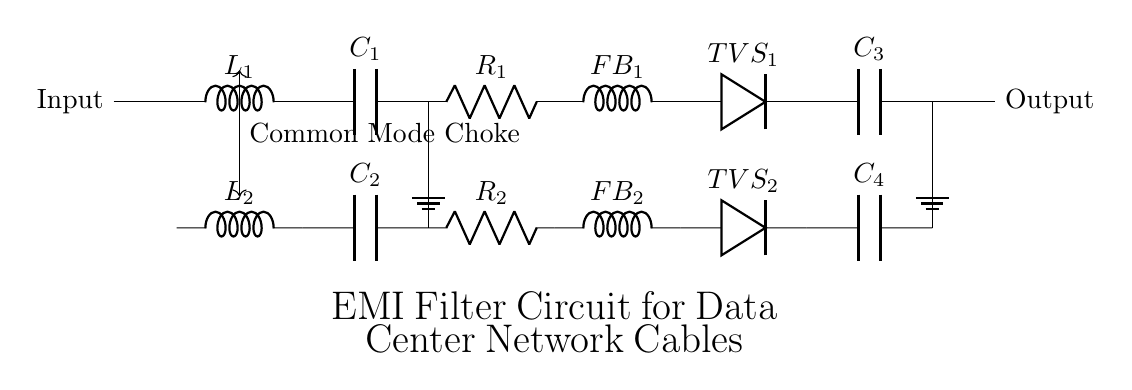What type of filter does this circuit implement? This circuit implements an electromagnetic interference filter, as indicated by the title and the presence of common mode chokes, capacitors, and resistors designed to reduce EMI effects on network cables.
Answer: electromagnetic interference filter How many inductors are present in the circuit? There are four inductors present in the circuit: two common mode chokes and two ferrite beads, which are integral components for filtering EMI.
Answer: four inductors What is connected to ground in this circuit? The circuit shows ground connections for multiple components; specifically, the resistors and output capacitors are connected to the ground to provide a reference point for voltages in the circuit.
Answer: resistors and output capacitors Why are TVS diodes included in this circuit? TVS diodes, or transient voltage suppressors, are included to protect the circuit from voltage spikes or transients, which can occur from EMI or lightning strikes, ensuring the integrity of the data transmission.
Answer: to protect from voltage spikes What is the purpose of the common mode choke in this circuit? The common mode choke is utilized to block high-frequency noise while allowing the desired data signals to pass, thereby helping to maintain signal integrity in the presence of electromagnetic interference.
Answer: to block high-frequency noise What types of components are used in the filtering section of the circuit? The filtering section employs inductors (common mode chokes and ferrite beads), capacitors, and resistors that work together to attenuate unwanted signals and provide a smooth output signal.
Answer: inductors, capacitors, resistors How many capacitors are in the circuit? The circuit contains four capacitors, which play a crucial role in filtering out interference by smoothing out voltage variations.
Answer: four capacitors 